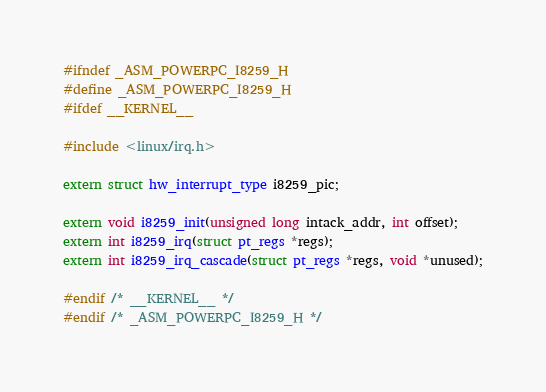<code> <loc_0><loc_0><loc_500><loc_500><_C_>#ifndef _ASM_POWERPC_I8259_H
#define _ASM_POWERPC_I8259_H
#ifdef __KERNEL__

#include <linux/irq.h>

extern struct hw_interrupt_type i8259_pic;

extern void i8259_init(unsigned long intack_addr, int offset);
extern int i8259_irq(struct pt_regs *regs);
extern int i8259_irq_cascade(struct pt_regs *regs, void *unused);

#endif /* __KERNEL__ */
#endif /* _ASM_POWERPC_I8259_H */
</code> 